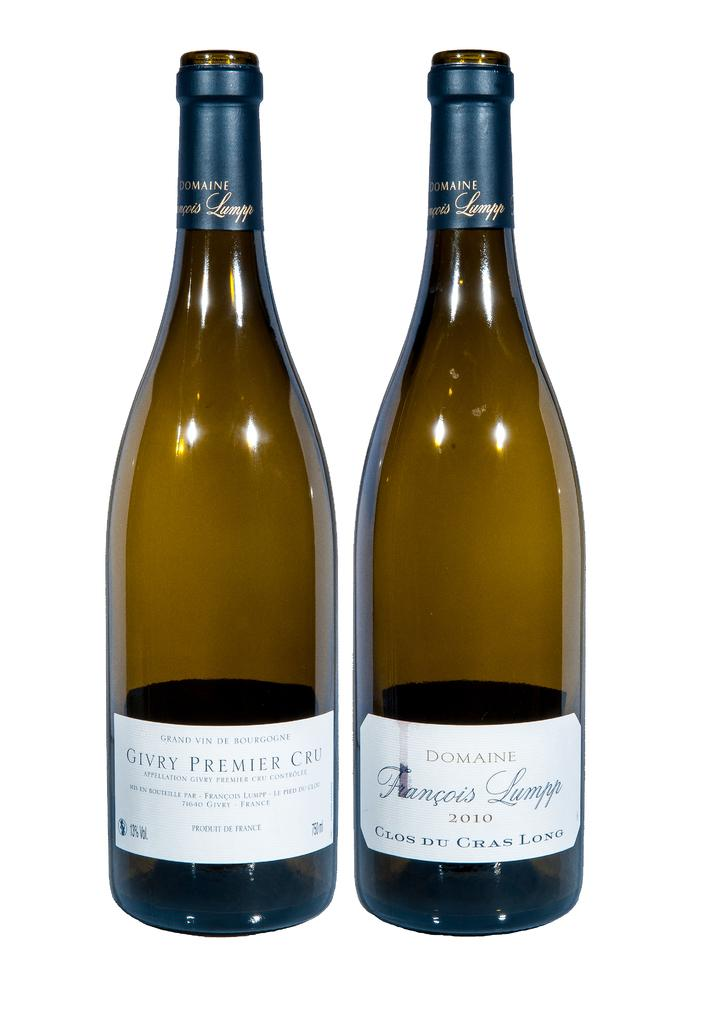<image>
Give a short and clear explanation of the subsequent image. Two dark amber colored glass wine bottles from Domaine in France. 